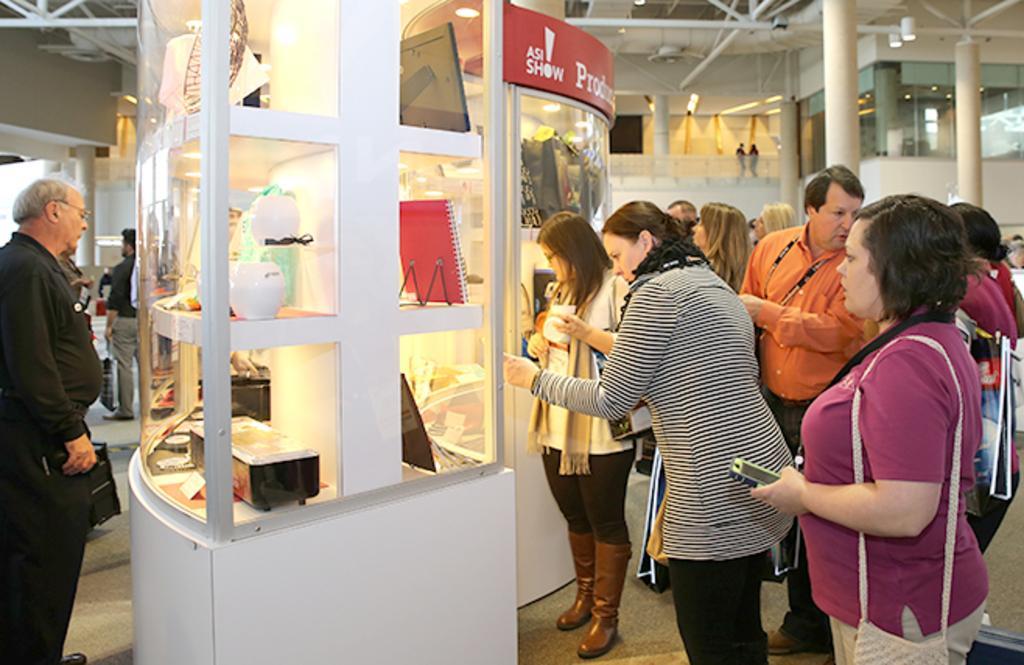In one or two sentences, can you explain what this image depicts? In this image there are group of persons standing, there are persons holding objects, there is a person truncated towards the left of the image, there are objects on the shelves, there is a board, there is text on the board, there is light, there is the roof, there is the wall truncated towards the right of the image, there is the wall truncated towards the left of the image, there are pipes. 